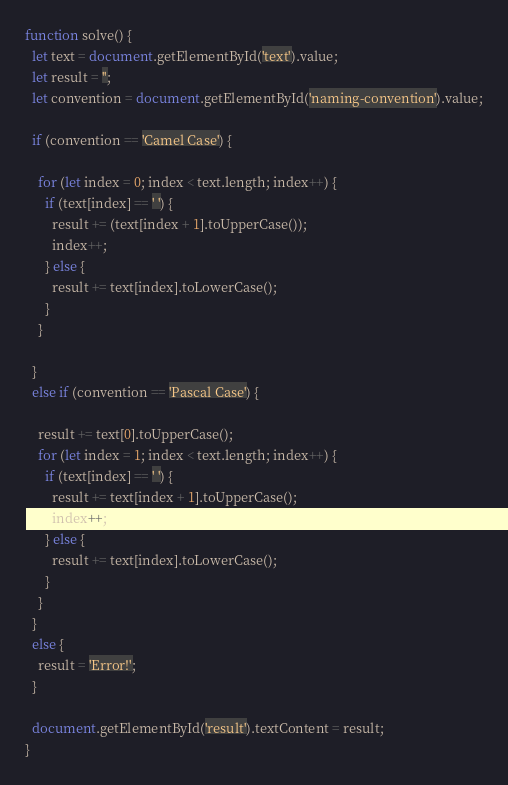Convert code to text. <code><loc_0><loc_0><loc_500><loc_500><_JavaScript_>function solve() {
  let text = document.getElementById('text').value;
  let result = '';
  let convention = document.getElementById('naming-convention').value;

  if (convention == 'Camel Case') {

    for (let index = 0; index < text.length; index++) {
      if (text[index] == ' ') {
        result += (text[index + 1].toUpperCase());
        index++;
      } else {
        result += text[index].toLowerCase();
      }
    }

  }
  else if (convention == 'Pascal Case') {

    result += text[0].toUpperCase();
    for (let index = 1; index < text.length; index++) {
      if (text[index] == ' ') {
        result += text[index + 1].toUpperCase();
        index++;
      } else {
        result += text[index].toLowerCase();
      }
    }
  }
  else {
    result = 'Error!';
  }

  document.getElementById('result').textContent = result;
}</code> 